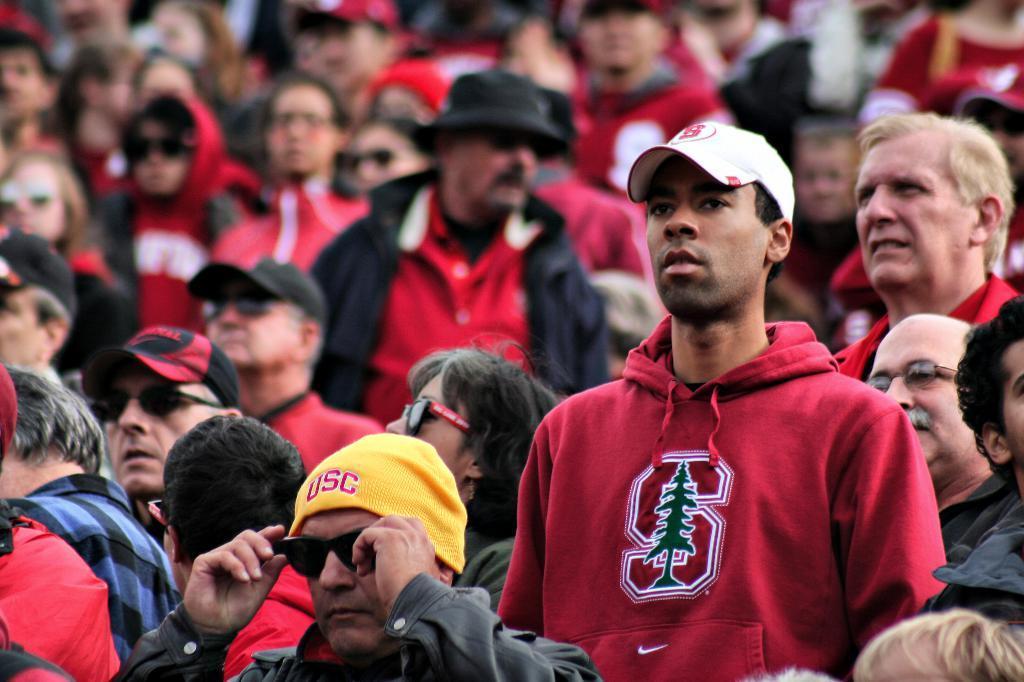Could you give a brief overview of what you see in this image? In this image we can see many people standing. 